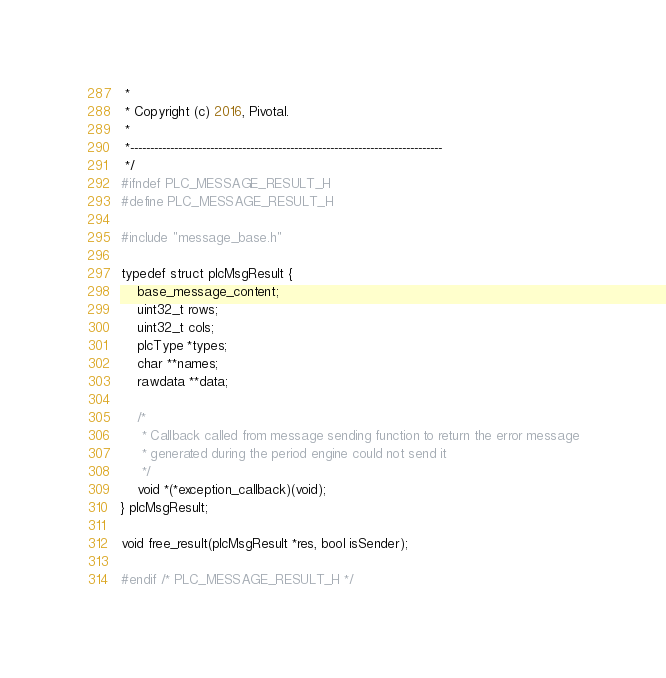<code> <loc_0><loc_0><loc_500><loc_500><_C_> *
 * Copyright (c) 2016, Pivotal.
 *
 *------------------------------------------------------------------------------
 */
#ifndef PLC_MESSAGE_RESULT_H
#define PLC_MESSAGE_RESULT_H

#include "message_base.h"

typedef struct plcMsgResult {
	base_message_content;
	uint32_t rows;
	uint32_t cols;
	plcType *types;
	char **names;
	rawdata **data;

	/*
	 * Callback called from message sending function to return the error message
	 * generated during the period engine could not send it
	 */
	void *(*exception_callback)(void);
} plcMsgResult;

void free_result(plcMsgResult *res, bool isSender);

#endif /* PLC_MESSAGE_RESULT_H */
</code> 